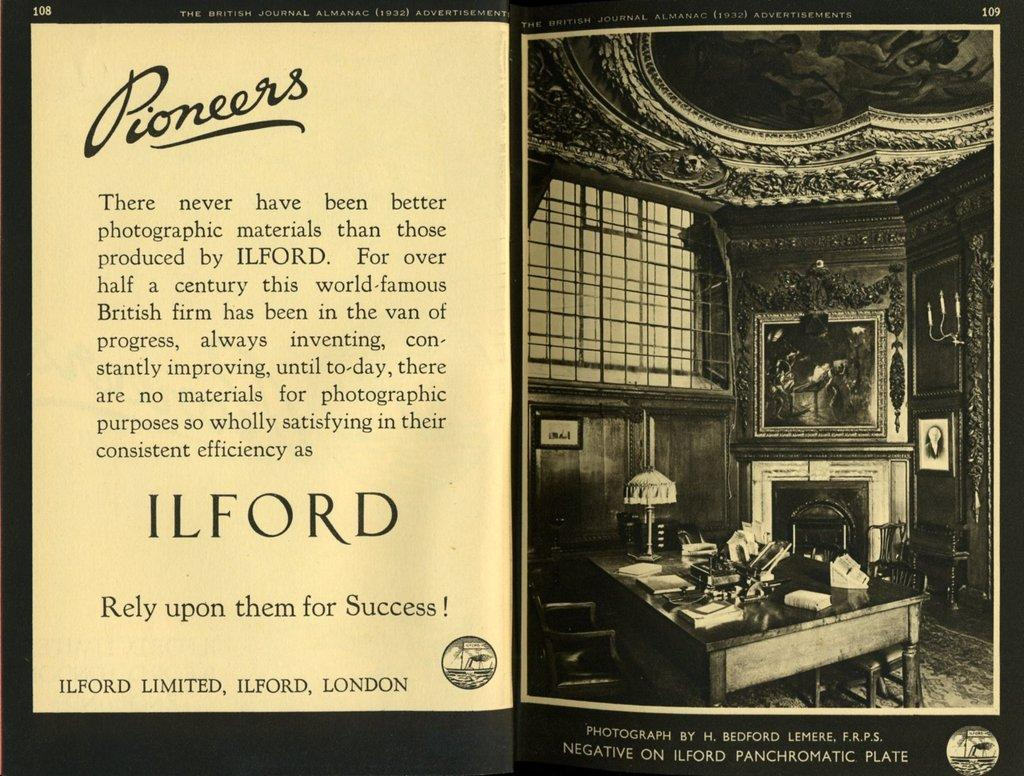<image>
Offer a succinct explanation of the picture presented. An advertisement for a photography company named Pioneers. 